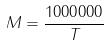Convert formula to latex. <formula><loc_0><loc_0><loc_500><loc_500>M = \frac { 1 0 0 0 0 0 0 } { T }</formula> 